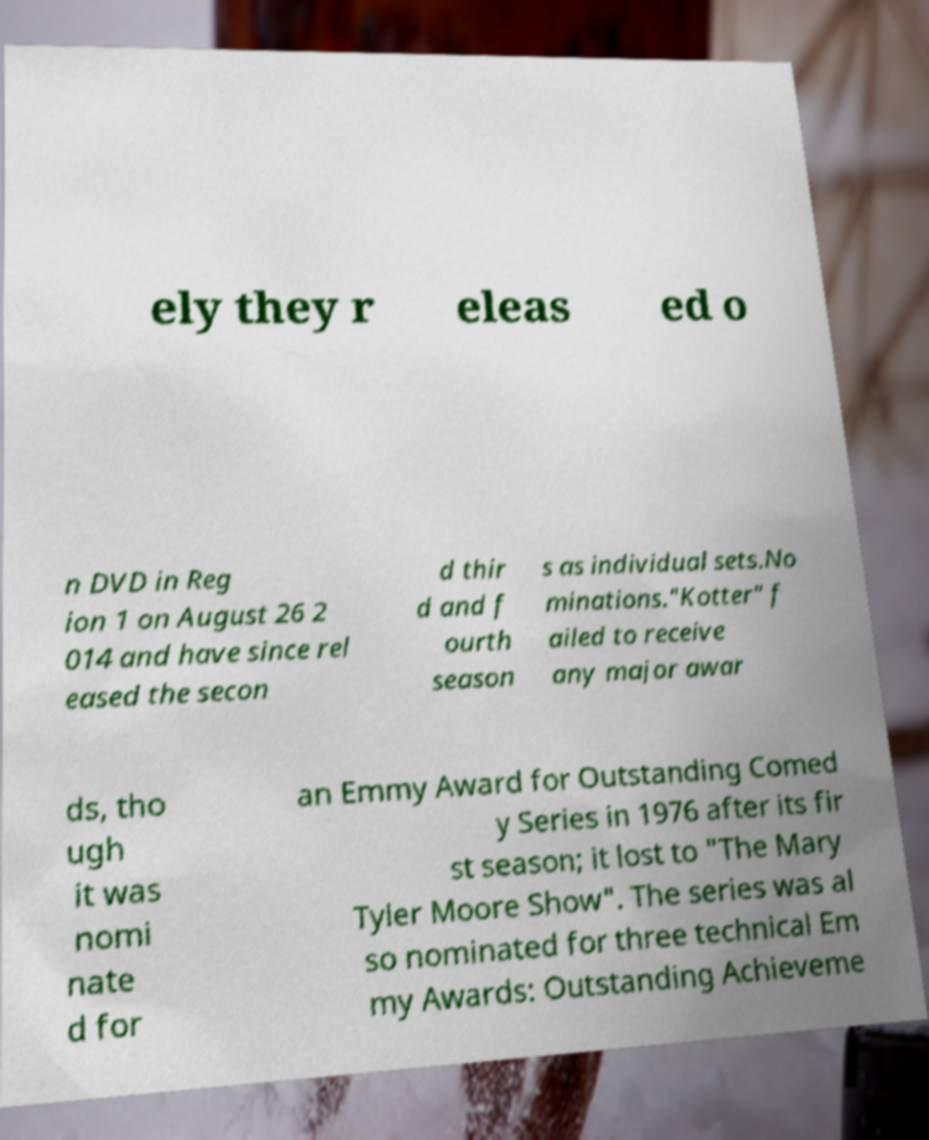Could you assist in decoding the text presented in this image and type it out clearly? ely they r eleas ed o n DVD in Reg ion 1 on August 26 2 014 and have since rel eased the secon d thir d and f ourth season s as individual sets.No minations."Kotter" f ailed to receive any major awar ds, tho ugh it was nomi nate d for an Emmy Award for Outstanding Comed y Series in 1976 after its fir st season; it lost to "The Mary Tyler Moore Show". The series was al so nominated for three technical Em my Awards: Outstanding Achieveme 